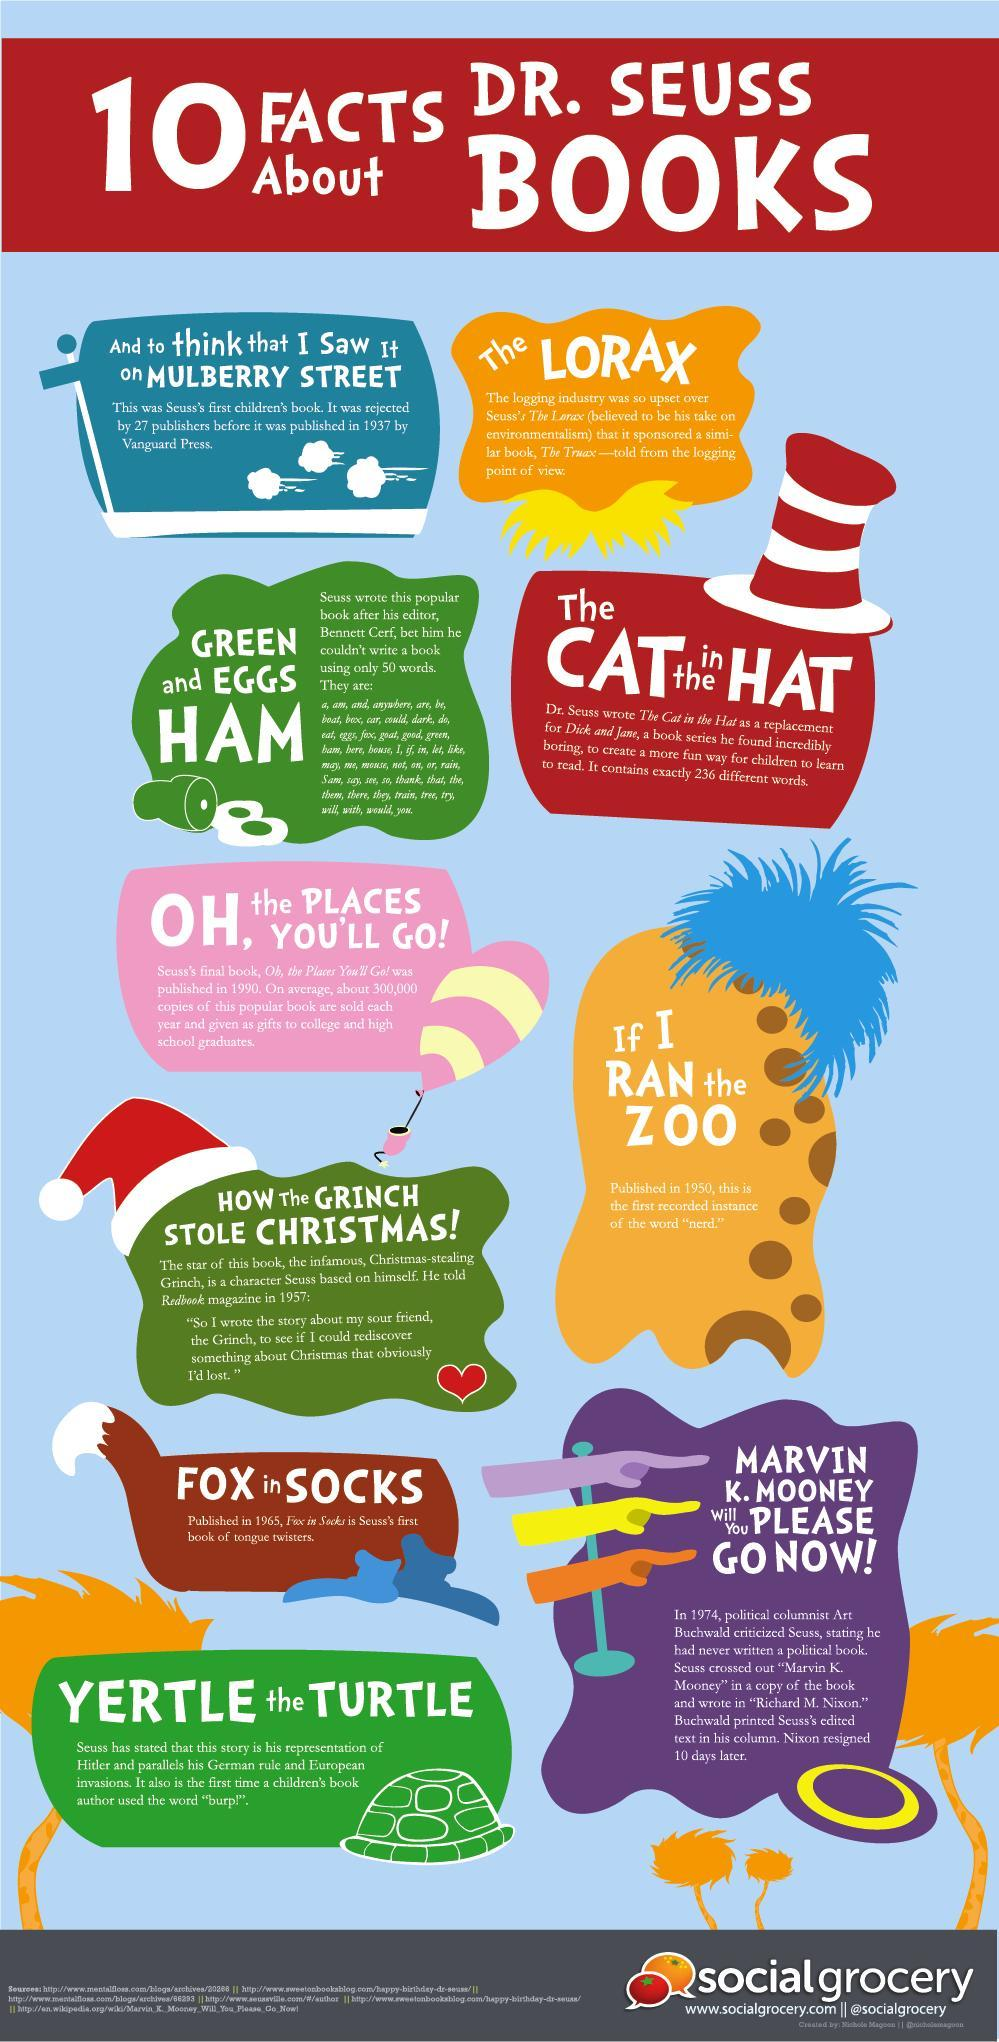How many Dr. Seuss books have animal names on its title?
Answer the question with a short phrase. 3 When was the author's first book printed, 1950, 1957, or 1937? 1937 Which book of the Dr. Seuss was not supportive of the timber business? The Lorax 